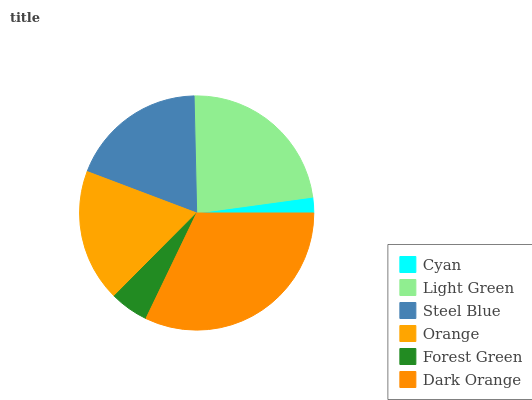Is Cyan the minimum?
Answer yes or no. Yes. Is Dark Orange the maximum?
Answer yes or no. Yes. Is Light Green the minimum?
Answer yes or no. No. Is Light Green the maximum?
Answer yes or no. No. Is Light Green greater than Cyan?
Answer yes or no. Yes. Is Cyan less than Light Green?
Answer yes or no. Yes. Is Cyan greater than Light Green?
Answer yes or no. No. Is Light Green less than Cyan?
Answer yes or no. No. Is Steel Blue the high median?
Answer yes or no. Yes. Is Orange the low median?
Answer yes or no. Yes. Is Forest Green the high median?
Answer yes or no. No. Is Light Green the low median?
Answer yes or no. No. 